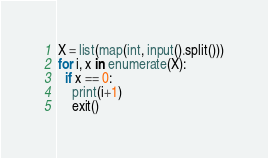Convert code to text. <code><loc_0><loc_0><loc_500><loc_500><_Python_>X = list(map(int, input().split()))
for i, x in enumerate(X):
  if x == 0:
    print(i+1)
    exit()</code> 